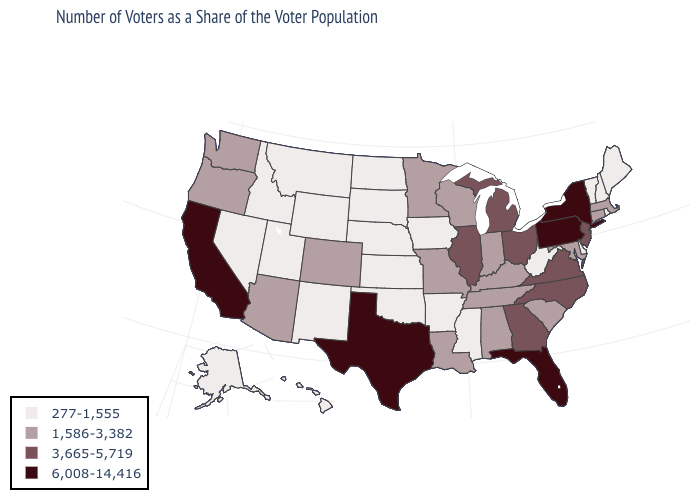Name the states that have a value in the range 1,586-3,382?
Be succinct. Alabama, Arizona, Colorado, Connecticut, Indiana, Kentucky, Louisiana, Maryland, Massachusetts, Minnesota, Missouri, Oregon, South Carolina, Tennessee, Washington, Wisconsin. What is the value of Oregon?
Short answer required. 1,586-3,382. Among the states that border Maryland , does Pennsylvania have the lowest value?
Keep it brief. No. Name the states that have a value in the range 277-1,555?
Concise answer only. Alaska, Arkansas, Delaware, Hawaii, Idaho, Iowa, Kansas, Maine, Mississippi, Montana, Nebraska, Nevada, New Hampshire, New Mexico, North Dakota, Oklahoma, Rhode Island, South Dakota, Utah, Vermont, West Virginia, Wyoming. Name the states that have a value in the range 277-1,555?
Keep it brief. Alaska, Arkansas, Delaware, Hawaii, Idaho, Iowa, Kansas, Maine, Mississippi, Montana, Nebraska, Nevada, New Hampshire, New Mexico, North Dakota, Oklahoma, Rhode Island, South Dakota, Utah, Vermont, West Virginia, Wyoming. What is the lowest value in the USA?
Keep it brief. 277-1,555. Name the states that have a value in the range 277-1,555?
Concise answer only. Alaska, Arkansas, Delaware, Hawaii, Idaho, Iowa, Kansas, Maine, Mississippi, Montana, Nebraska, Nevada, New Hampshire, New Mexico, North Dakota, Oklahoma, Rhode Island, South Dakota, Utah, Vermont, West Virginia, Wyoming. Among the states that border Massachusetts , which have the highest value?
Quick response, please. New York. Is the legend a continuous bar?
Give a very brief answer. No. What is the value of South Dakota?
Quick response, please. 277-1,555. Does Michigan have the highest value in the MidWest?
Answer briefly. Yes. Does South Dakota have the lowest value in the MidWest?
Concise answer only. Yes. What is the value of Maine?
Concise answer only. 277-1,555. Does Utah have the lowest value in the USA?
Answer briefly. Yes. What is the value of Michigan?
Be succinct. 3,665-5,719. 